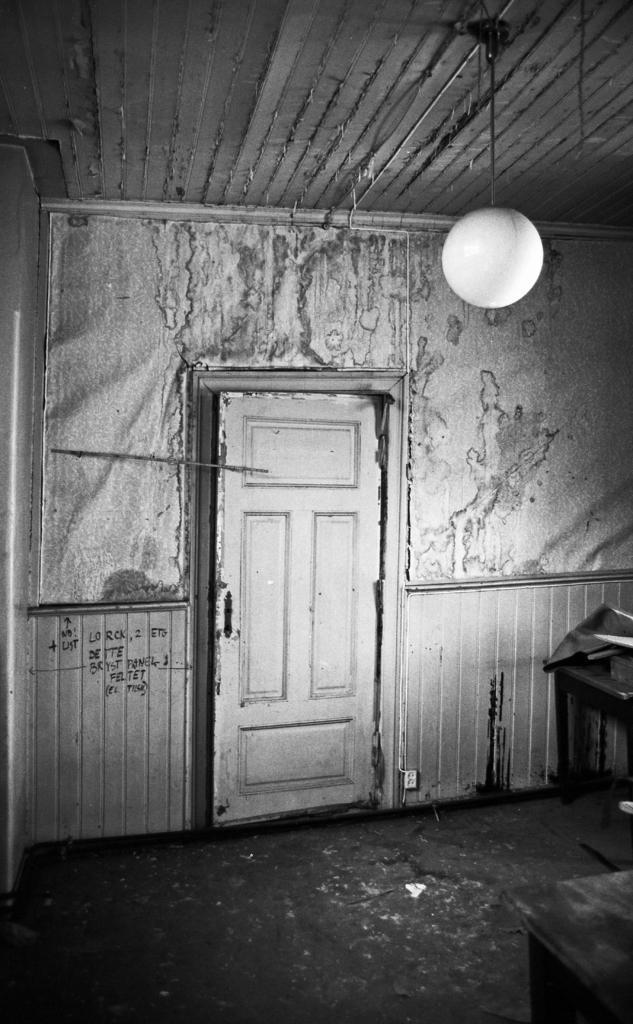Can you describe this image briefly? The image is in black and white, there we can see a door, there is a wall, there is a light. 